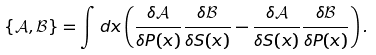Convert formula to latex. <formula><loc_0><loc_0><loc_500><loc_500>\{ \mathcal { A } , \mathcal { B } \} = \int d x \left ( \frac { \delta \mathcal { A } } { \delta P ( x ) } \frac { \delta \mathcal { B } } { \delta S ( x ) } - \frac { \delta \mathcal { A } } { \delta S ( x ) } \frac { \delta \mathcal { B } } { \delta P ( x ) } \right ) .</formula> 